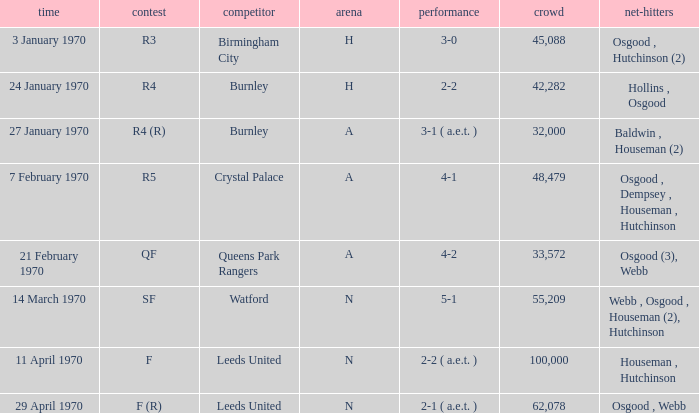What round was the game against Watford? SF. 